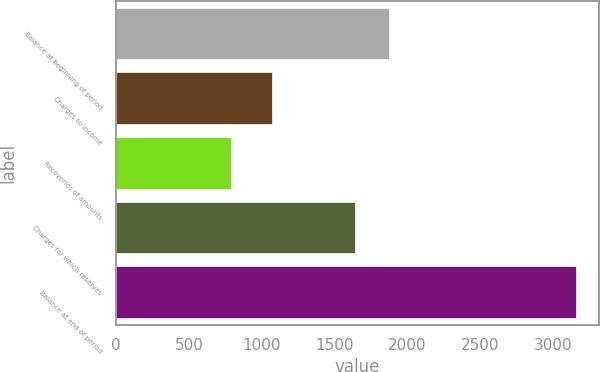Convert chart to OTSL. <chart><loc_0><loc_0><loc_500><loc_500><bar_chart><fcel>Balance at beginning of period<fcel>Charges to income<fcel>Recoveries of amounts<fcel>Charges for which reserves<fcel>Balance at end of period<nl><fcel>1876.6<fcel>1074<fcel>792<fcel>1640<fcel>3158<nl></chart> 